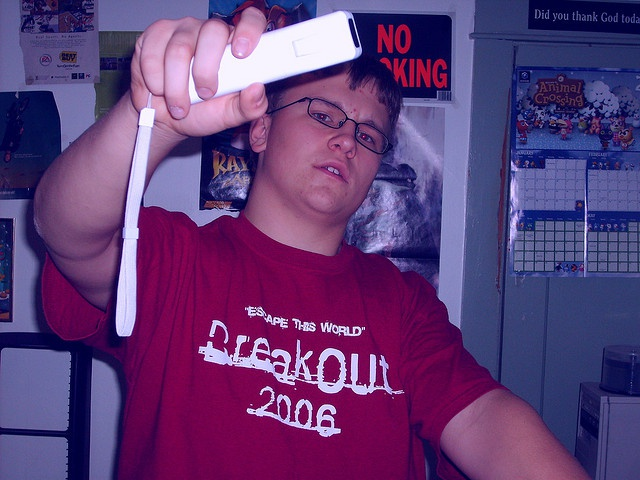Describe the objects in this image and their specific colors. I can see people in purple, violet, and navy tones and remote in purple, lavender, violet, and navy tones in this image. 